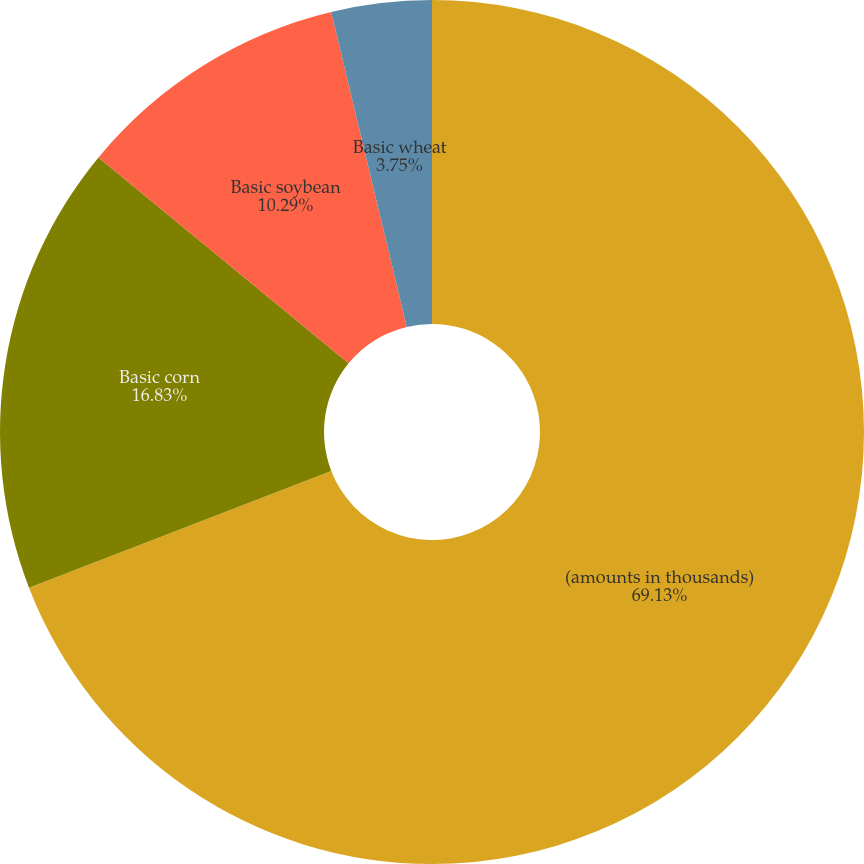Convert chart. <chart><loc_0><loc_0><loc_500><loc_500><pie_chart><fcel>(amounts in thousands)<fcel>Basic corn<fcel>Basic soybean<fcel>Basic wheat<nl><fcel>69.14%<fcel>16.83%<fcel>10.29%<fcel>3.75%<nl></chart> 